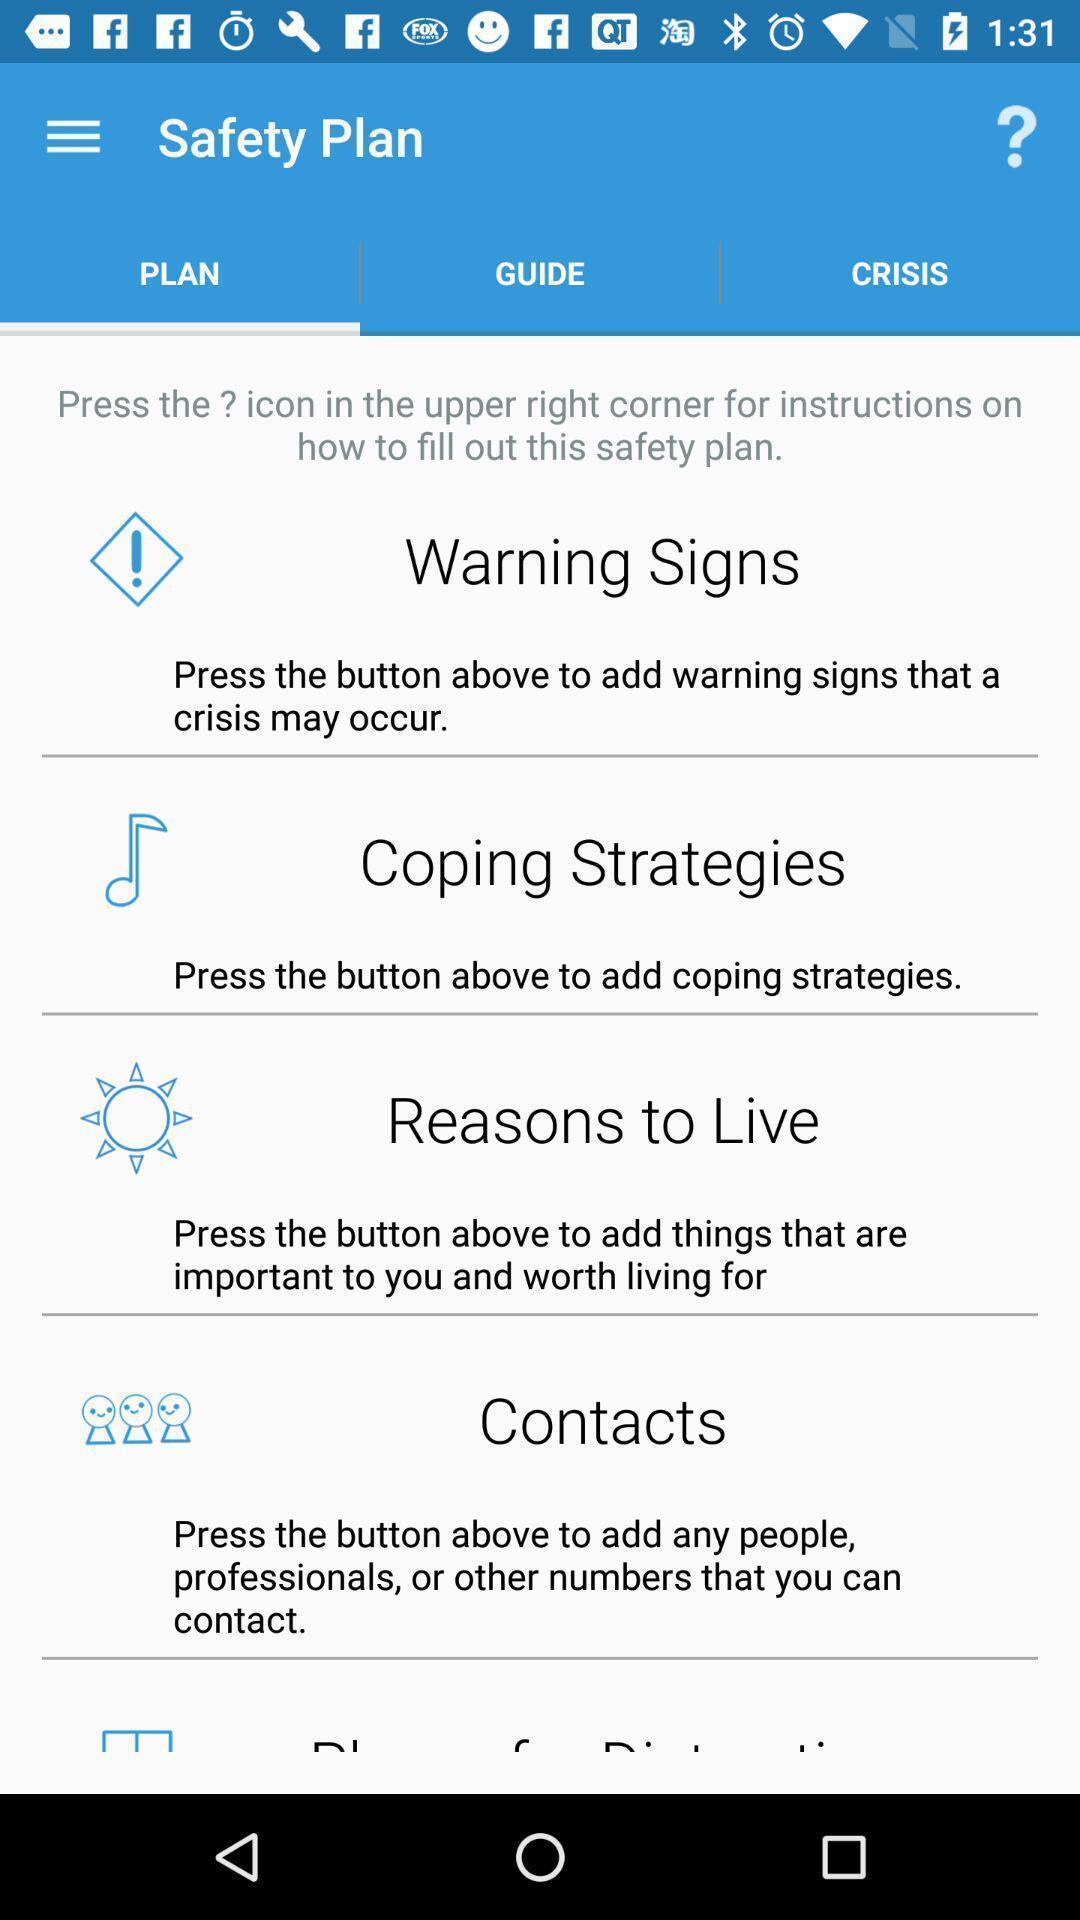Please provide a description for this image. Screen shows plan page in therapy application. 